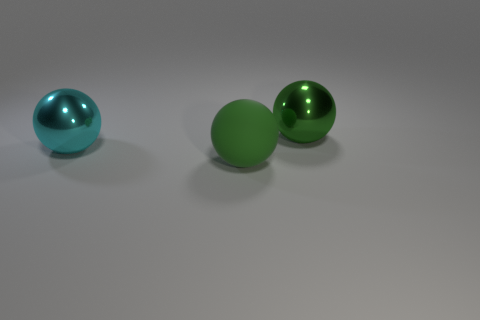There is a metallic ball on the right side of the cyan metallic sphere; how big is it?
Offer a terse response. Large. What is the green ball left of the large shiny thing that is right of the green ball that is in front of the big green metallic thing made of?
Make the answer very short. Rubber. Is the shape of the big green rubber thing the same as the large green metallic thing?
Ensure brevity in your answer.  Yes. What number of rubber things are either big things or small yellow cylinders?
Your response must be concise. 1. What number of large red rubber things are there?
Your response must be concise. 0. What color is the other shiny object that is the same size as the green metal thing?
Your response must be concise. Cyan. Is the size of the matte object the same as the cyan ball?
Provide a succinct answer. Yes. What shape is the large metal thing that is the same color as the rubber sphere?
Give a very brief answer. Sphere. There is a green matte thing; does it have the same size as the object on the left side of the big green rubber ball?
Provide a short and direct response. Yes. There is a large object that is right of the large cyan shiny ball and behind the large green matte sphere; what is its color?
Your answer should be compact. Green. 